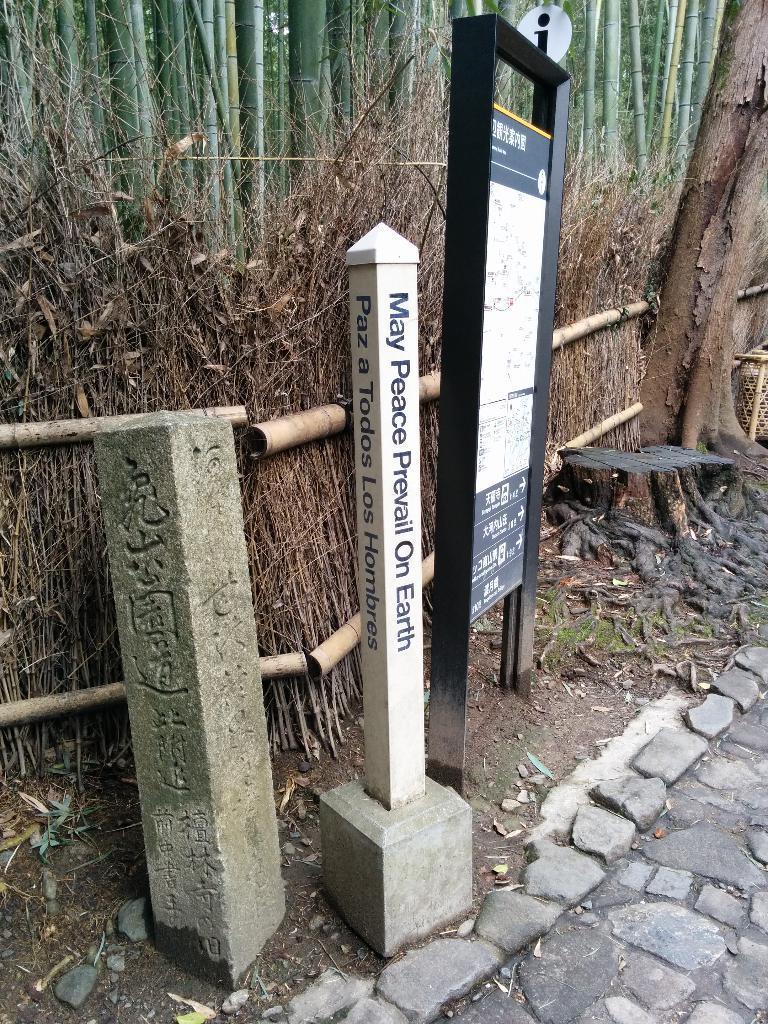In one or two sentences, can you explain what this image depicts? In this image we can see a board, pole and a barrier stone on the ground with some text on them. We can also see some stones, the stump of a tree, the bark of a tree and the fence made with the branches and some poles. On the top of the image we can see a group of bamboo shoots. 